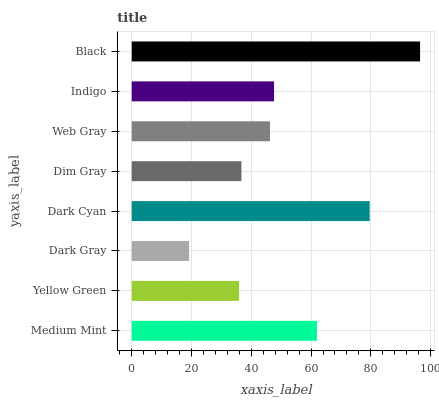Is Dark Gray the minimum?
Answer yes or no. Yes. Is Black the maximum?
Answer yes or no. Yes. Is Yellow Green the minimum?
Answer yes or no. No. Is Yellow Green the maximum?
Answer yes or no. No. Is Medium Mint greater than Yellow Green?
Answer yes or no. Yes. Is Yellow Green less than Medium Mint?
Answer yes or no. Yes. Is Yellow Green greater than Medium Mint?
Answer yes or no. No. Is Medium Mint less than Yellow Green?
Answer yes or no. No. Is Indigo the high median?
Answer yes or no. Yes. Is Web Gray the low median?
Answer yes or no. Yes. Is Yellow Green the high median?
Answer yes or no. No. Is Dark Gray the low median?
Answer yes or no. No. 